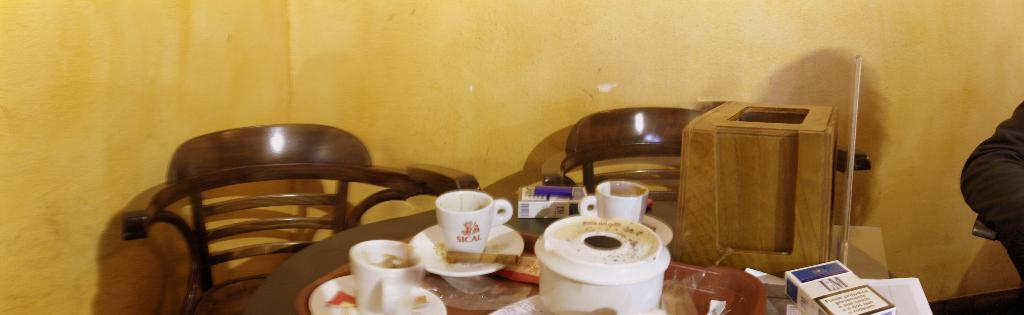What type of furniture is present in the image? There is a table and chairs in the image. What objects are placed on the table? There are cups and saucers on the table, along with other unspecified items. How many chairs are visible in the image? The number of chairs is not specified, but there are chairs present in the image. What type of arm is visible on the table in the image? There is no arm visible on the table in the image. What kind of magic is being performed in the image? There is no magic or any indication of a magical event in the image. 